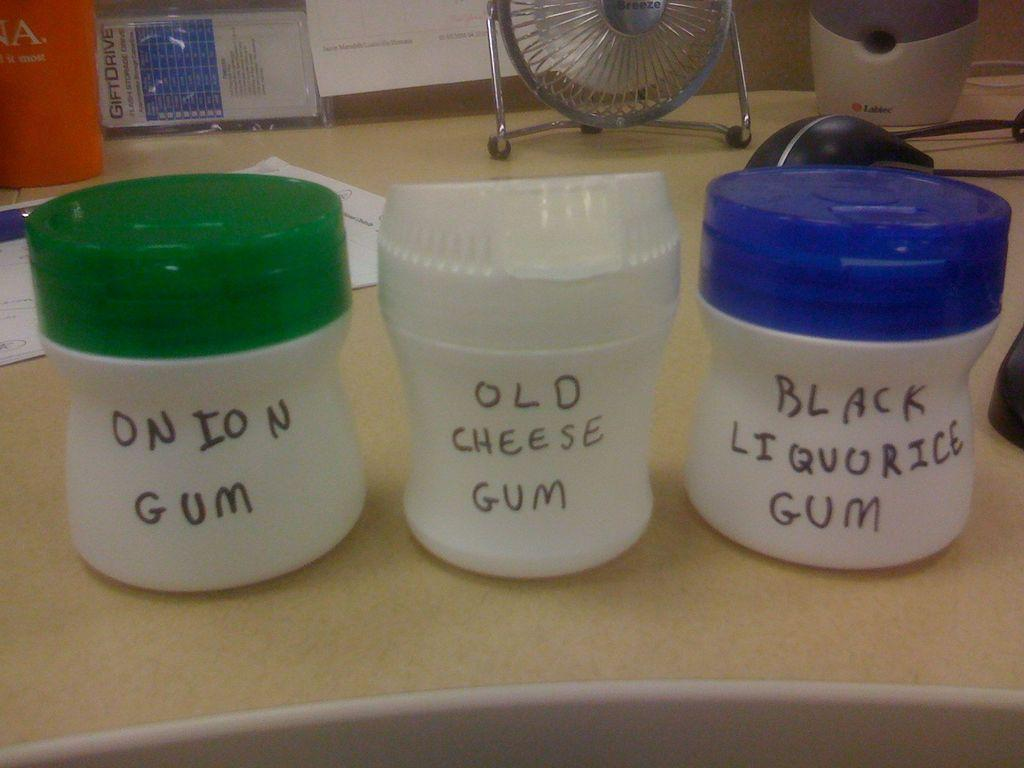<image>
Share a concise interpretation of the image provided. A sortment of gum in different containers on a table. 